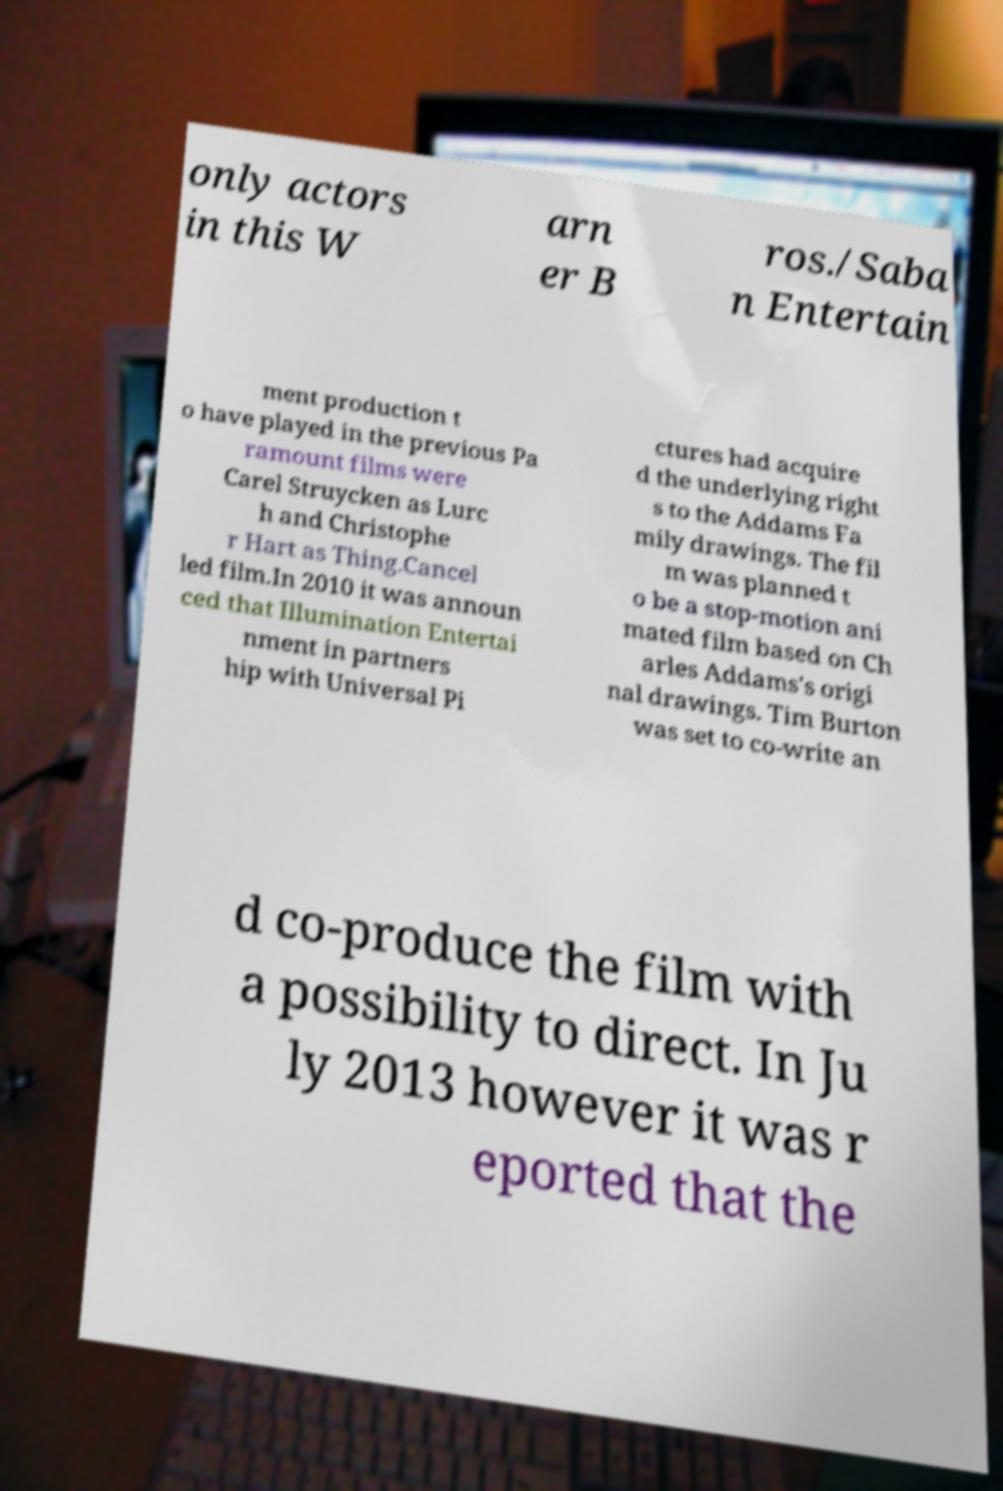Please read and relay the text visible in this image. What does it say? only actors in this W arn er B ros./Saba n Entertain ment production t o have played in the previous Pa ramount films were Carel Struycken as Lurc h and Christophe r Hart as Thing.Cancel led film.In 2010 it was announ ced that Illumination Entertai nment in partners hip with Universal Pi ctures had acquire d the underlying right s to the Addams Fa mily drawings. The fil m was planned t o be a stop-motion ani mated film based on Ch arles Addams's origi nal drawings. Tim Burton was set to co-write an d co-produce the film with a possibility to direct. In Ju ly 2013 however it was r eported that the 